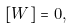<formula> <loc_0><loc_0><loc_500><loc_500>[ W ] = 0 ,</formula> 